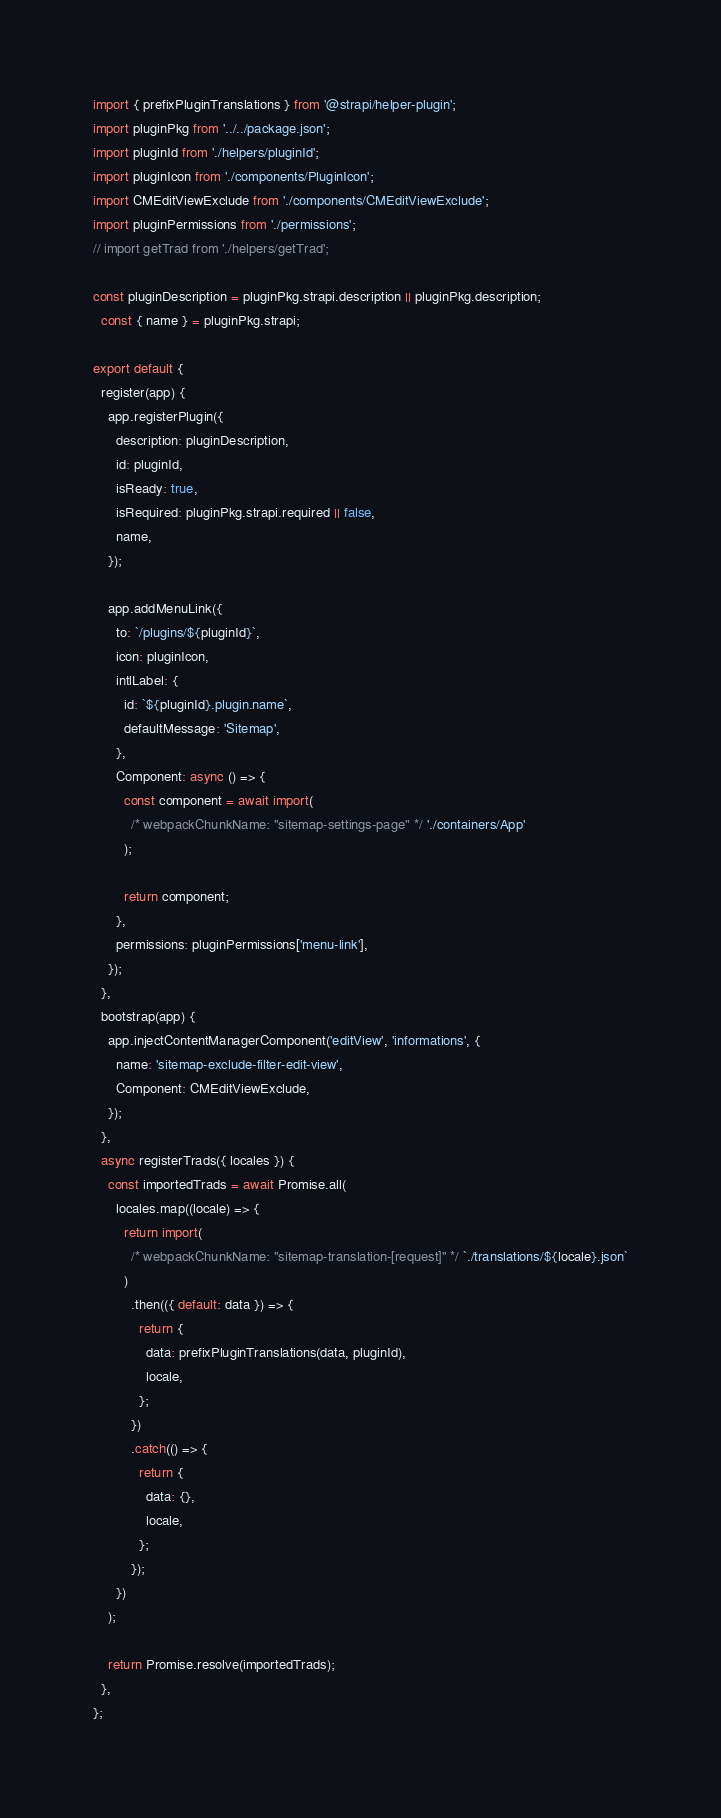<code> <loc_0><loc_0><loc_500><loc_500><_JavaScript_>import { prefixPluginTranslations } from '@strapi/helper-plugin';
import pluginPkg from '../../package.json';
import pluginId from './helpers/pluginId';
import pluginIcon from './components/PluginIcon';
import CMEditViewExclude from './components/CMEditViewExclude';
import pluginPermissions from './permissions';
// import getTrad from './helpers/getTrad';

const pluginDescription = pluginPkg.strapi.description || pluginPkg.description;
  const { name } = pluginPkg.strapi;

export default {
  register(app) {
    app.registerPlugin({
      description: pluginDescription,
      id: pluginId,
      isReady: true,
      isRequired: pluginPkg.strapi.required || false,
      name,
    });

    app.addMenuLink({
      to: `/plugins/${pluginId}`,
      icon: pluginIcon,
      intlLabel: {
        id: `${pluginId}.plugin.name`,
        defaultMessage: 'Sitemap',
      },
      Component: async () => {
        const component = await import(
          /* webpackChunkName: "sitemap-settings-page" */ './containers/App'
        );

        return component;
      },
      permissions: pluginPermissions['menu-link'],
    });
  },
  bootstrap(app) {
    app.injectContentManagerComponent('editView', 'informations', {
      name: 'sitemap-exclude-filter-edit-view',
      Component: CMEditViewExclude,
    });
  },
  async registerTrads({ locales }) {
    const importedTrads = await Promise.all(
      locales.map((locale) => {
        return import(
          /* webpackChunkName: "sitemap-translation-[request]" */ `./translations/${locale}.json`
        )
          .then(({ default: data }) => {
            return {
              data: prefixPluginTranslations(data, pluginId),
              locale,
            };
          })
          .catch(() => {
            return {
              data: {},
              locale,
            };
          });
      })
    );

    return Promise.resolve(importedTrads);
  },
};
</code> 